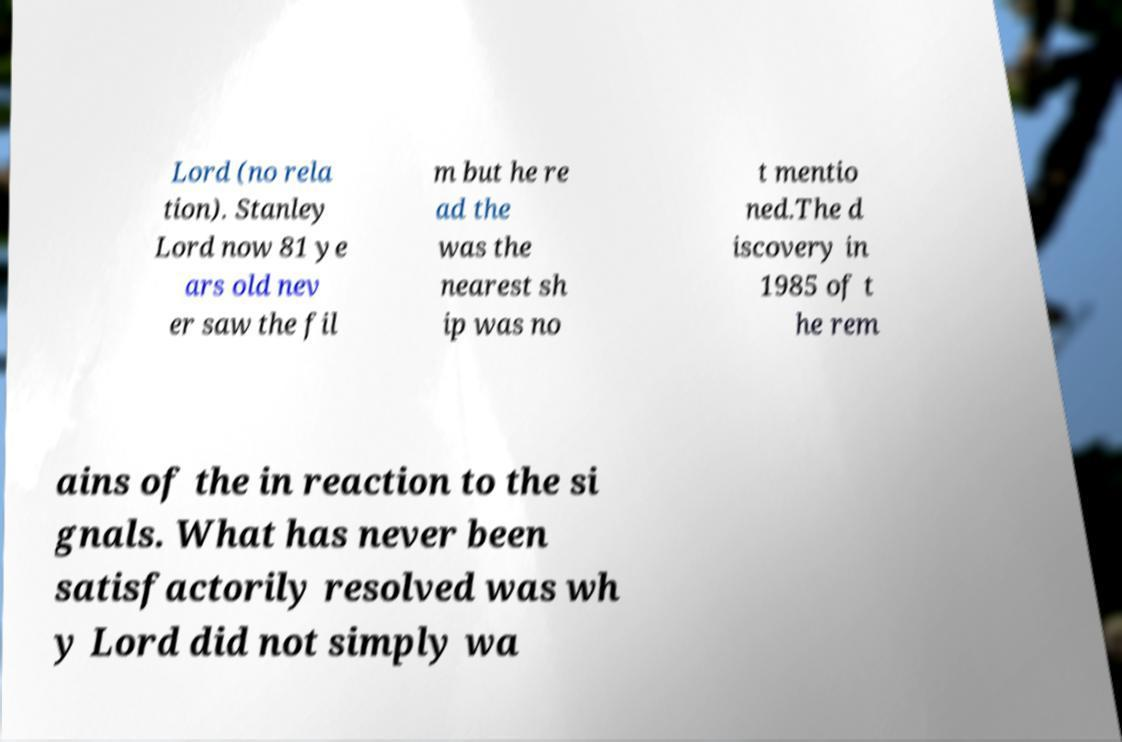Please identify and transcribe the text found in this image. Lord (no rela tion). Stanley Lord now 81 ye ars old nev er saw the fil m but he re ad the was the nearest sh ip was no t mentio ned.The d iscovery in 1985 of t he rem ains of the in reaction to the si gnals. What has never been satisfactorily resolved was wh y Lord did not simply wa 